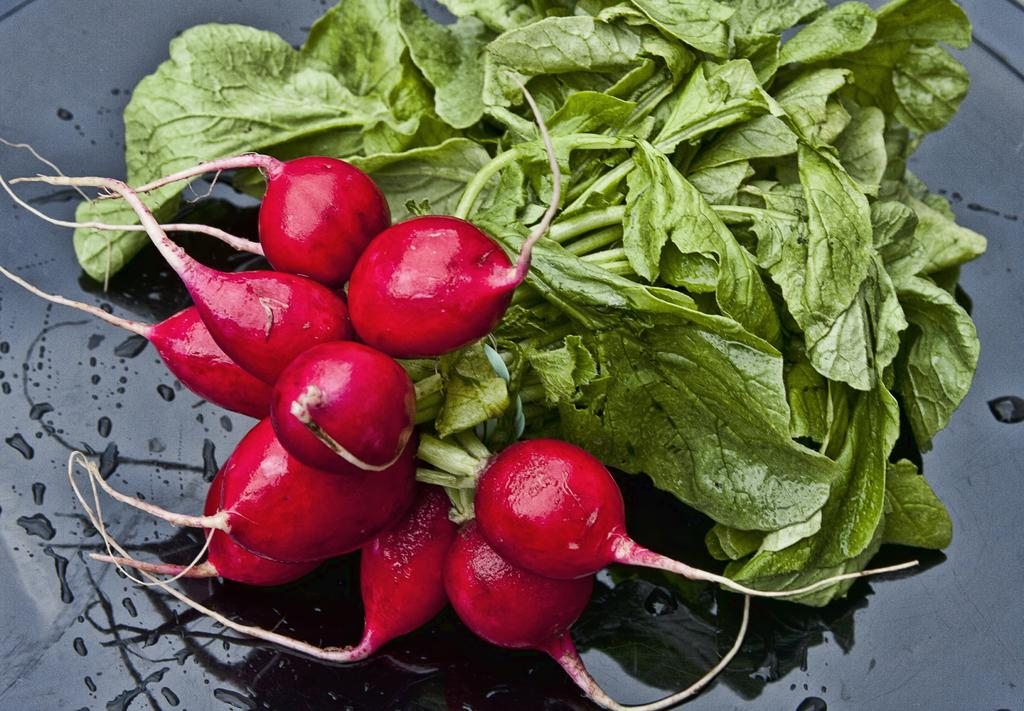What type of vegetable is present in the image? There are beetroot in the image. What part of the beetroot is also visible? The beetroot have leaves. Where are the beetroot and leaves located? The beetroot and leaves are on a table. How many books are stacked on the lamp in the image? There are no books or lamps present in the image; it only features beetroot and leaves on a table. 